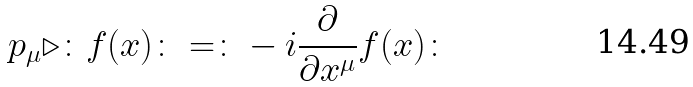<formula> <loc_0><loc_0><loc_500><loc_500>p _ { \mu } \triangleright \colon f ( x ) \colon = \colon - i \frac { \partial } { \partial x ^ { \mu } } f ( x ) \colon</formula> 